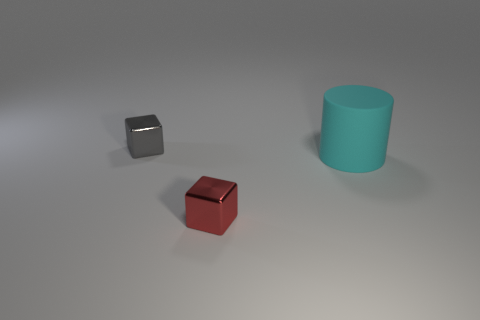Add 2 large cyan rubber cylinders. How many objects exist? 5 Subtract all cylinders. How many objects are left? 2 Subtract all small cyan shiny cylinders. Subtract all shiny objects. How many objects are left? 1 Add 1 small red blocks. How many small red blocks are left? 2 Add 1 large shiny cylinders. How many large shiny cylinders exist? 1 Subtract 0 brown blocks. How many objects are left? 3 